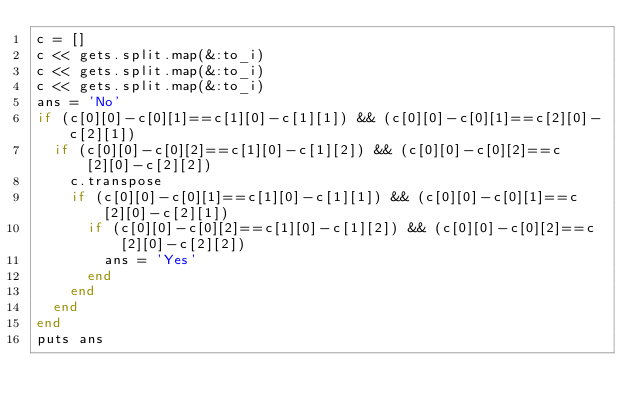<code> <loc_0><loc_0><loc_500><loc_500><_Ruby_>c = []
c << gets.split.map(&:to_i)
c << gets.split.map(&:to_i)
c << gets.split.map(&:to_i)
ans = 'No'
if (c[0][0]-c[0][1]==c[1][0]-c[1][1]) && (c[0][0]-c[0][1]==c[2][0]-c[2][1])
  if (c[0][0]-c[0][2]==c[1][0]-c[1][2]) && (c[0][0]-c[0][2]==c[2][0]-c[2][2])
    c.transpose
    if (c[0][0]-c[0][1]==c[1][0]-c[1][1]) && (c[0][0]-c[0][1]==c[2][0]-c[2][1])
      if (c[0][0]-c[0][2]==c[1][0]-c[1][2]) && (c[0][0]-c[0][2]==c[2][0]-c[2][2])
        ans = 'Yes'
      end
    end
  end
end
puts ans
</code> 